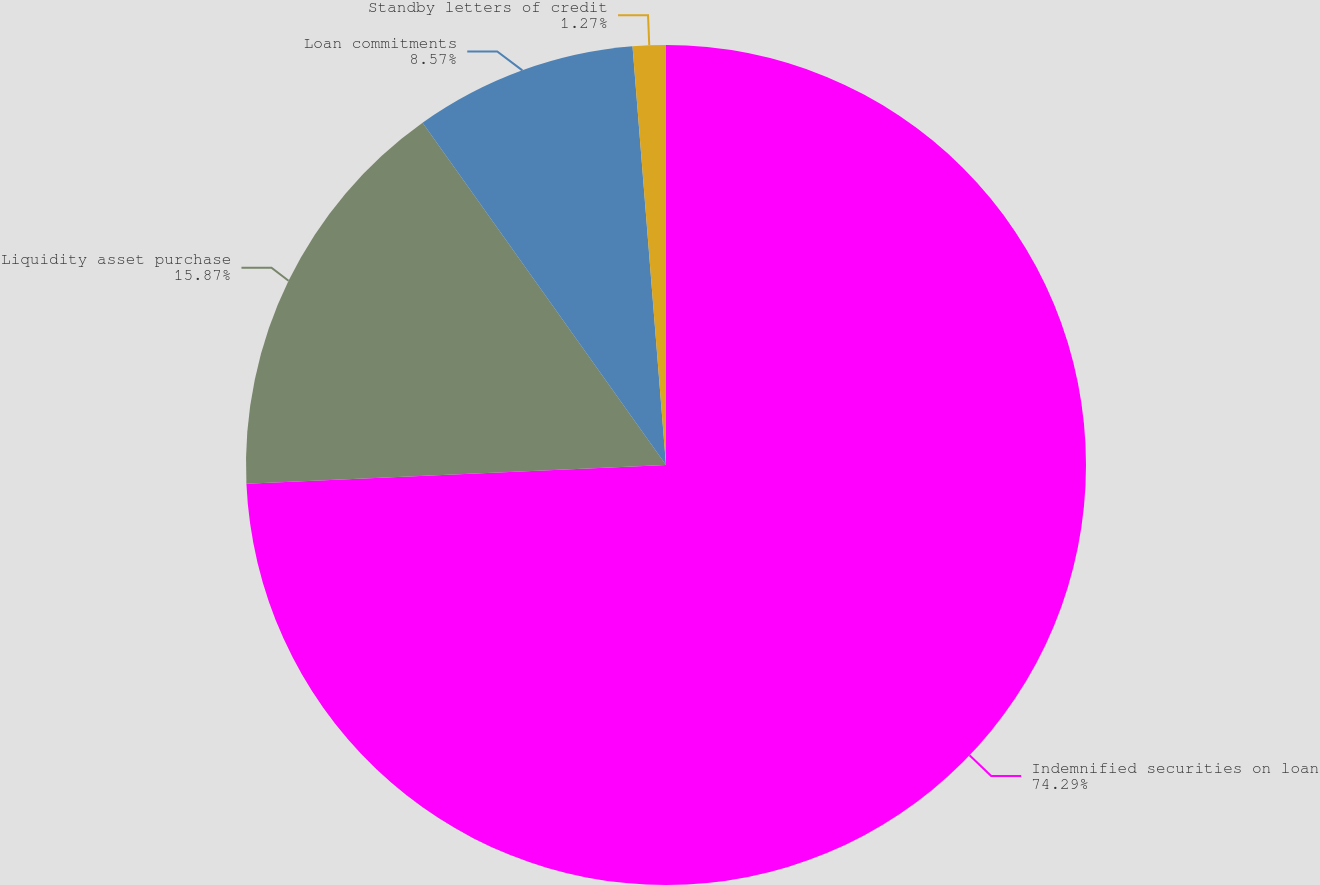Convert chart to OTSL. <chart><loc_0><loc_0><loc_500><loc_500><pie_chart><fcel>Indemnified securities on loan<fcel>Liquidity asset purchase<fcel>Loan commitments<fcel>Standby letters of credit<nl><fcel>74.29%<fcel>15.87%<fcel>8.57%<fcel>1.27%<nl></chart> 